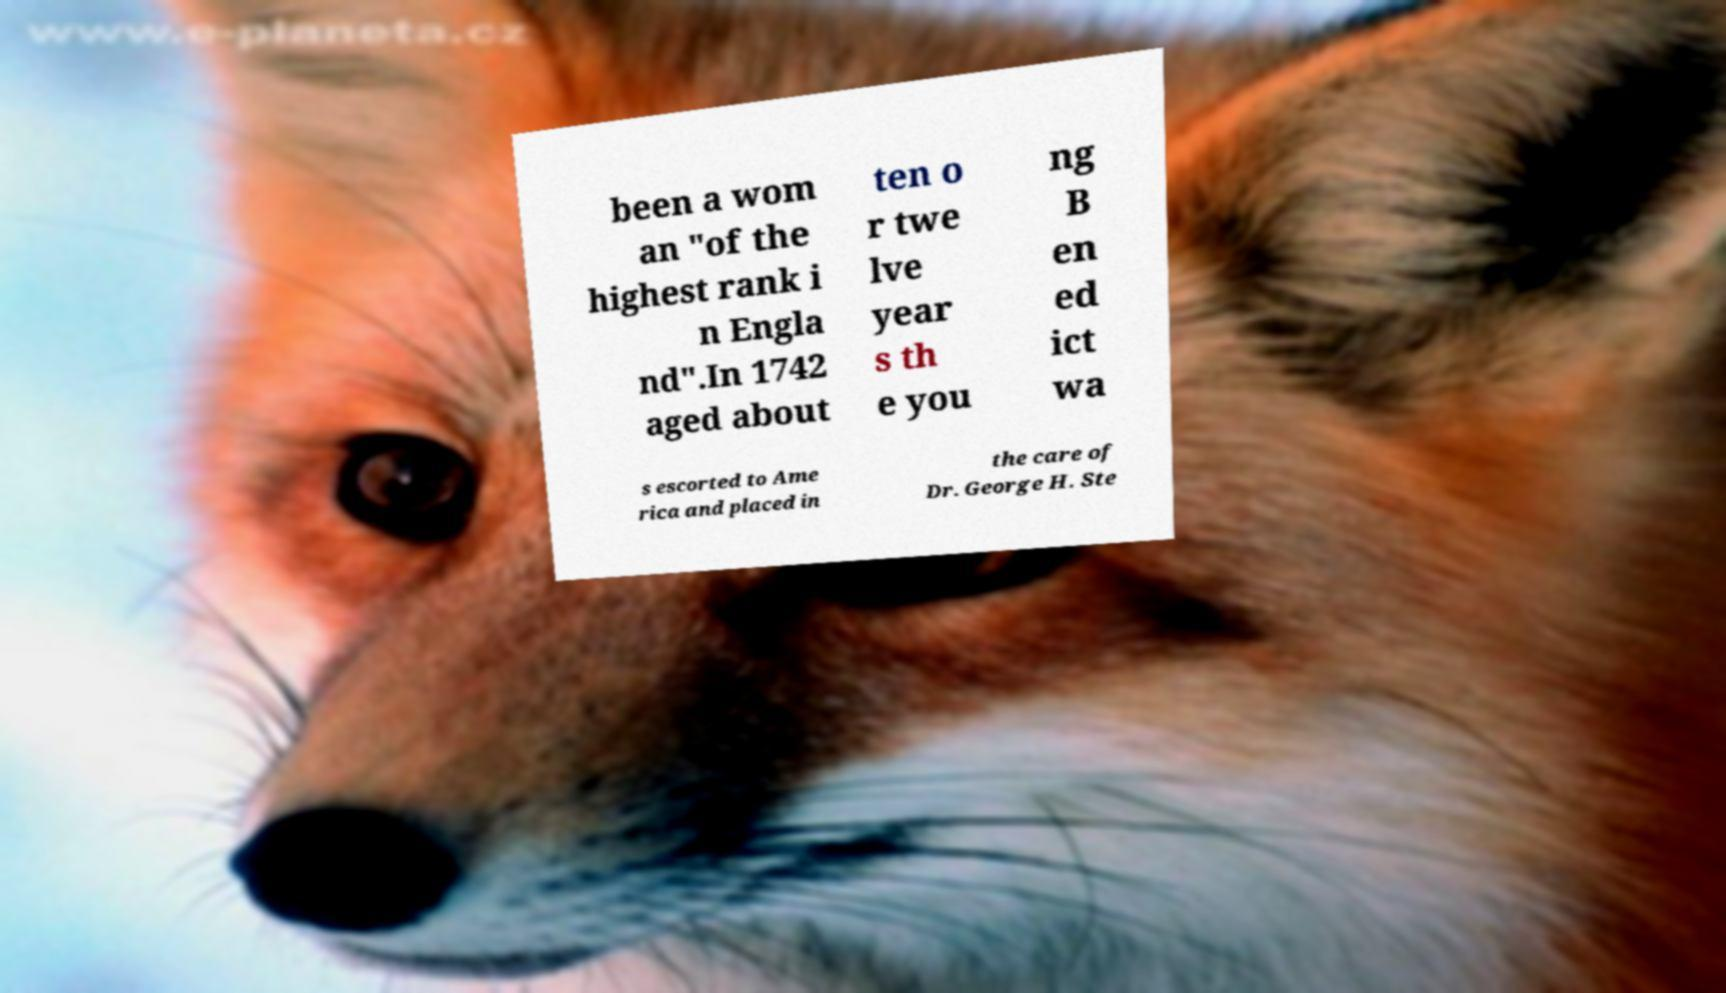Could you assist in decoding the text presented in this image and type it out clearly? been a wom an "of the highest rank i n Engla nd".In 1742 aged about ten o r twe lve year s th e you ng B en ed ict wa s escorted to Ame rica and placed in the care of Dr. George H. Ste 